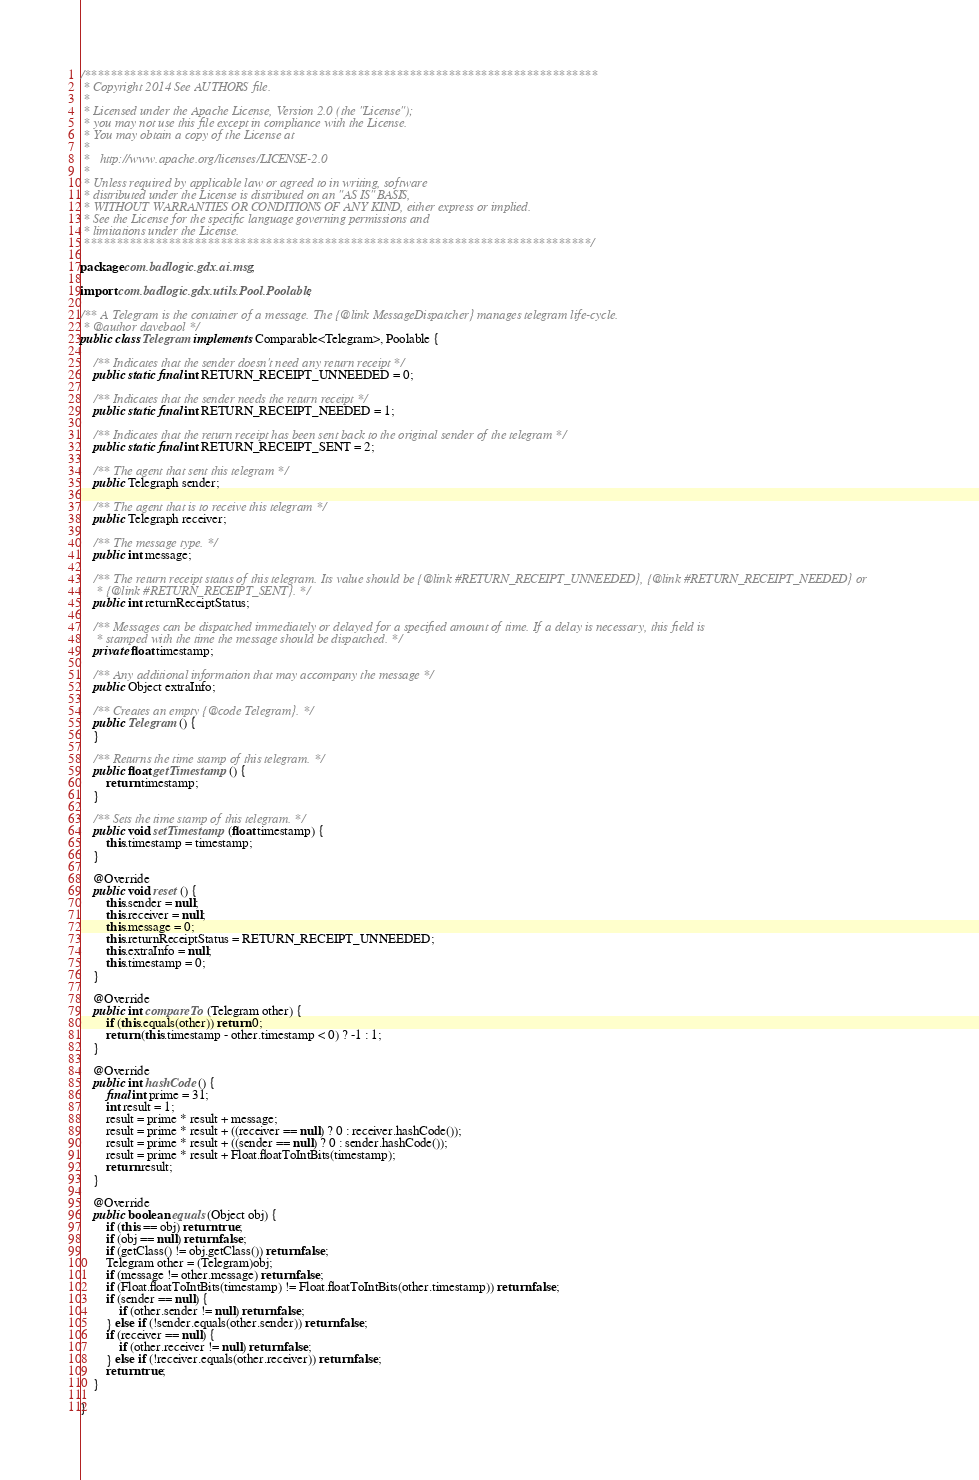<code> <loc_0><loc_0><loc_500><loc_500><_Java_>/*******************************************************************************
 * Copyright 2014 See AUTHORS file.
 * 
 * Licensed under the Apache License, Version 2.0 (the "License");
 * you may not use this file except in compliance with the License.
 * You may obtain a copy of the License at
 * 
 *   http://www.apache.org/licenses/LICENSE-2.0
 * 
 * Unless required by applicable law or agreed to in writing, software
 * distributed under the License is distributed on an "AS IS" BASIS,
 * WITHOUT WARRANTIES OR CONDITIONS OF ANY KIND, either express or implied.
 * See the License for the specific language governing permissions and
 * limitations under the License.
 ******************************************************************************/

package com.badlogic.gdx.ai.msg;

import com.badlogic.gdx.utils.Pool.Poolable;

/** A Telegram is the container of a message. The {@link MessageDispatcher} manages telegram life-cycle.
 * @author davebaol */
public class Telegram implements Comparable<Telegram>, Poolable {

	/** Indicates that the sender doesn't need any return receipt */
	public static final int RETURN_RECEIPT_UNNEEDED = 0;

	/** Indicates that the sender needs the return receipt */
	public static final int RETURN_RECEIPT_NEEDED = 1;

	/** Indicates that the return receipt has been sent back to the original sender of the telegram */
	public static final int RETURN_RECEIPT_SENT = 2;

	/** The agent that sent this telegram */
	public Telegraph sender;

	/** The agent that is to receive this telegram */
	public Telegraph receiver;

	/** The message type. */
	public int message;

	/** The return receipt status of this telegram. Its value should be {@link #RETURN_RECEIPT_UNNEEDED}, {@link #RETURN_RECEIPT_NEEDED} or
	 * {@link #RETURN_RECEIPT_SENT}. */
	public int returnReceiptStatus;

	/** Messages can be dispatched immediately or delayed for a specified amount of time. If a delay is necessary, this field is
	 * stamped with the time the message should be dispatched. */
	private float timestamp;

	/** Any additional information that may accompany the message */
	public Object extraInfo;

	/** Creates an empty {@code Telegram}. */
	public Telegram () {
	}

	/** Returns the time stamp of this telegram. */
	public float getTimestamp () {
		return timestamp;
	}

	/** Sets the time stamp of this telegram. */
	public void setTimestamp (float timestamp) {
		this.timestamp = timestamp;
	}

	@Override
	public void reset () {
		this.sender = null;
		this.receiver = null;
		this.message = 0;
		this.returnReceiptStatus = RETURN_RECEIPT_UNNEEDED;
		this.extraInfo = null;
		this.timestamp = 0;
	}

	@Override
	public int compareTo (Telegram other) {
		if (this.equals(other)) return 0;
		return (this.timestamp - other.timestamp < 0) ? -1 : 1;
	}

	@Override
	public int hashCode () {
		final int prime = 31;
		int result = 1;
		result = prime * result + message;
		result = prime * result + ((receiver == null) ? 0 : receiver.hashCode());
		result = prime * result + ((sender == null) ? 0 : sender.hashCode());
		result = prime * result + Float.floatToIntBits(timestamp);
		return result;
	}

	@Override
	public boolean equals (Object obj) {
		if (this == obj) return true;
		if (obj == null) return false;
		if (getClass() != obj.getClass()) return false;
		Telegram other = (Telegram)obj;
		if (message != other.message) return false;
		if (Float.floatToIntBits(timestamp) != Float.floatToIntBits(other.timestamp)) return false;
		if (sender == null) {
			if (other.sender != null) return false;
		} else if (!sender.equals(other.sender)) return false;
		if (receiver == null) {
			if (other.receiver != null) return false;
		} else if (!receiver.equals(other.receiver)) return false;
		return true;
	}

}
</code> 